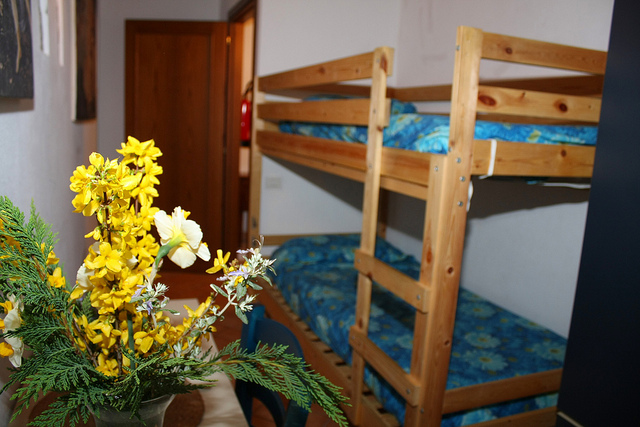<image>What is under the bed? I am not sure what is under the bed. It could be drawers, another bed, or nothing. What is under the bed? I don't know what is under the bed. It can be drawers, floor, another bed, or trunk. 